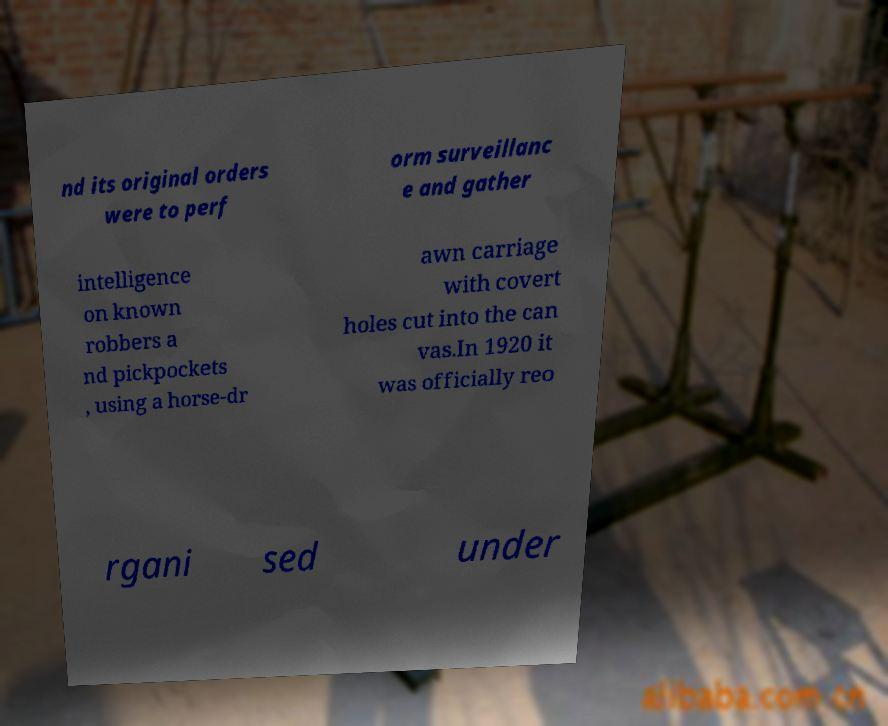Could you assist in decoding the text presented in this image and type it out clearly? nd its original orders were to perf orm surveillanc e and gather intelligence on known robbers a nd pickpockets , using a horse-dr awn carriage with covert holes cut into the can vas.In 1920 it was officially reo rgani sed under 